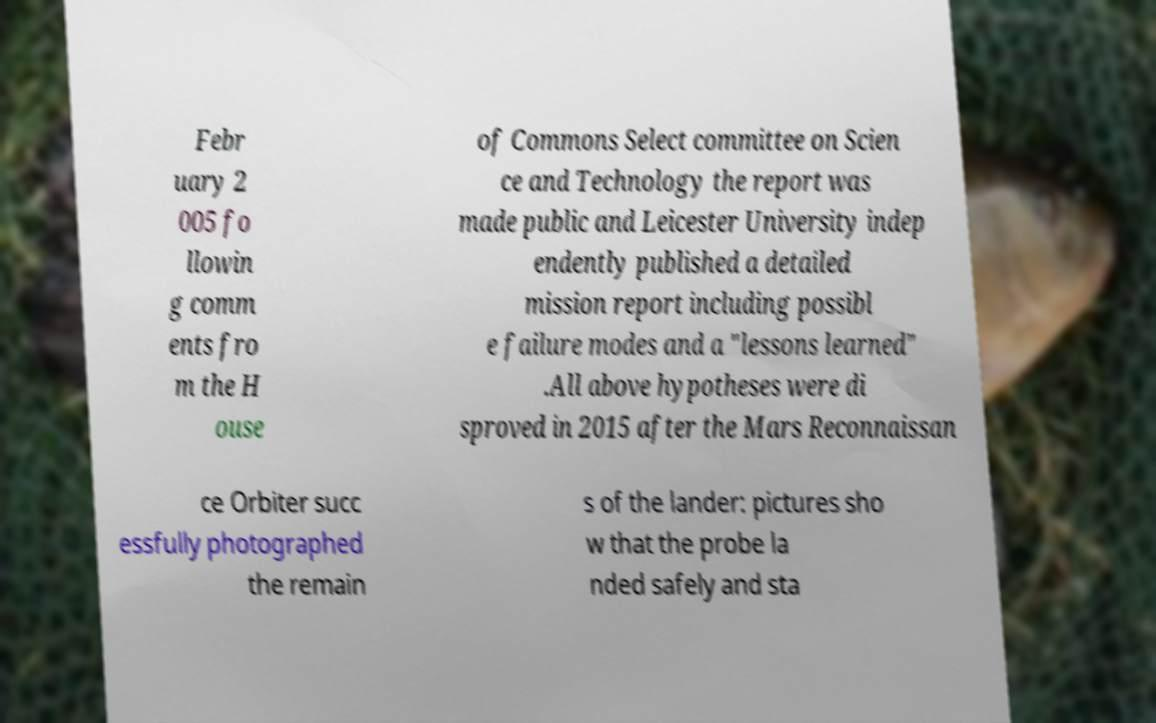Could you extract and type out the text from this image? Febr uary 2 005 fo llowin g comm ents fro m the H ouse of Commons Select committee on Scien ce and Technology the report was made public and Leicester University indep endently published a detailed mission report including possibl e failure modes and a "lessons learned" .All above hypotheses were di sproved in 2015 after the Mars Reconnaissan ce Orbiter succ essfully photographed the remain s of the lander: pictures sho w that the probe la nded safely and sta 